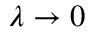Convert formula to latex. <formula><loc_0><loc_0><loc_500><loc_500>\lambda \to 0</formula> 